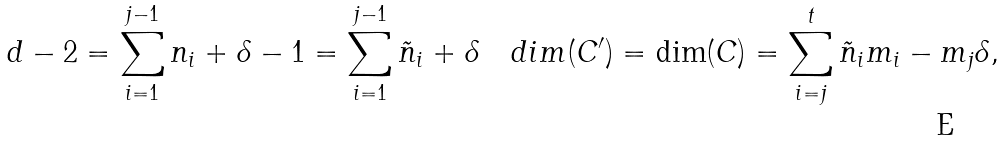<formula> <loc_0><loc_0><loc_500><loc_500>d - 2 = \sum _ { i = 1 } ^ { j - 1 } n _ { i } + \delta - 1 = \sum _ { i = 1 } ^ { j - 1 } \tilde { n } _ { i } + \delta \quad d i m ( C ^ { \prime } ) = \dim ( C ) = \sum _ { i = j } ^ { t } \tilde { n } _ { i } m _ { i } - m _ { j } \delta ,</formula> 